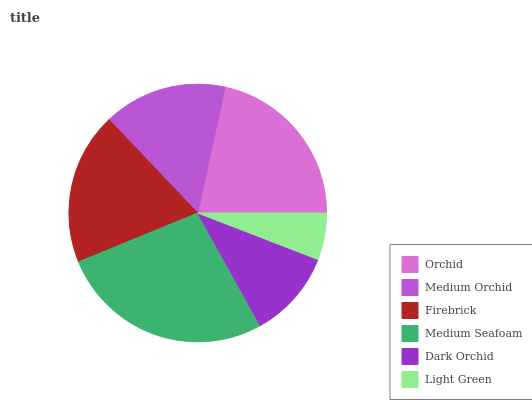Is Light Green the minimum?
Answer yes or no. Yes. Is Medium Seafoam the maximum?
Answer yes or no. Yes. Is Medium Orchid the minimum?
Answer yes or no. No. Is Medium Orchid the maximum?
Answer yes or no. No. Is Orchid greater than Medium Orchid?
Answer yes or no. Yes. Is Medium Orchid less than Orchid?
Answer yes or no. Yes. Is Medium Orchid greater than Orchid?
Answer yes or no. No. Is Orchid less than Medium Orchid?
Answer yes or no. No. Is Firebrick the high median?
Answer yes or no. Yes. Is Medium Orchid the low median?
Answer yes or no. Yes. Is Medium Orchid the high median?
Answer yes or no. No. Is Orchid the low median?
Answer yes or no. No. 